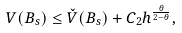<formula> <loc_0><loc_0><loc_500><loc_500>V ( B _ { s } ) \leq \check { V } ( B _ { s } ) + C _ { 2 } h ^ { \frac { \theta } { 2 - \theta } } ,</formula> 